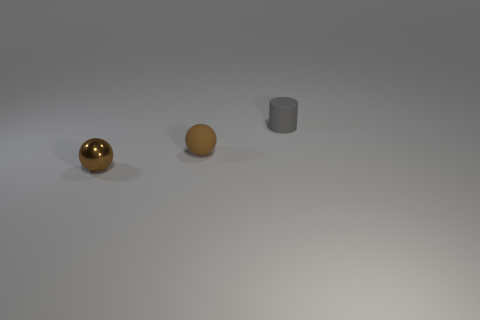How many things are both behind the small brown shiny sphere and on the left side of the tiny gray object? If we're considering the image from our viewpoint, there is one object that is both behind the small brown shiny sphere and to the left of the tiny gray object, which appears to be the medium-sized matte sphere. 